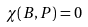<formula> <loc_0><loc_0><loc_500><loc_500>\chi ( B , P ) = 0</formula> 